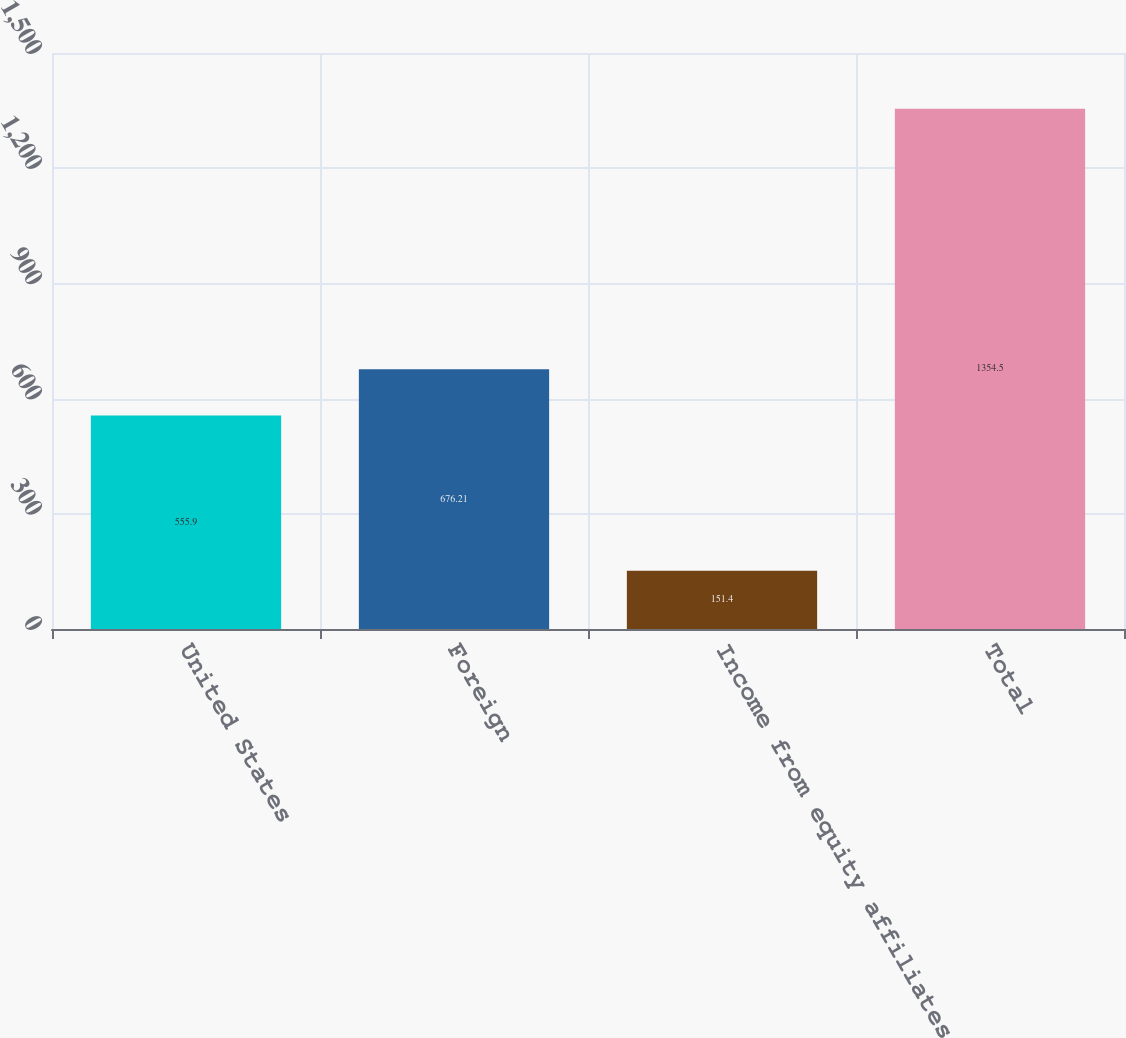<chart> <loc_0><loc_0><loc_500><loc_500><bar_chart><fcel>United States<fcel>Foreign<fcel>Income from equity affiliates<fcel>Total<nl><fcel>555.9<fcel>676.21<fcel>151.4<fcel>1354.5<nl></chart> 